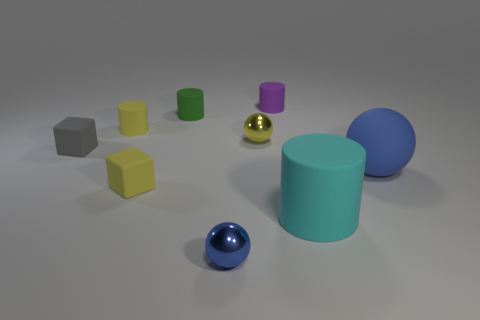What number of cyan objects are large matte cylinders or large rubber things?
Offer a terse response. 1. There is another tiny block that is the same material as the small gray block; what is its color?
Your answer should be very brief. Yellow. What number of large objects are either blue rubber things or cyan cylinders?
Your response must be concise. 2. Are there fewer matte balls than small brown blocks?
Offer a very short reply. No. There is another large rubber thing that is the same shape as the purple rubber thing; what color is it?
Provide a succinct answer. Cyan. Are there more things than yellow matte cubes?
Make the answer very short. Yes. What number of other objects are the same material as the large cylinder?
Make the answer very short. 6. The shiny thing on the left side of the small metallic object that is right of the tiny thing that is in front of the cyan rubber cylinder is what shape?
Provide a short and direct response. Sphere. Is the number of big cyan rubber cylinders that are in front of the large cyan thing less than the number of matte objects that are in front of the small purple matte object?
Your answer should be very brief. Yes. Are there any tiny things that have the same color as the large matte ball?
Provide a succinct answer. Yes. 